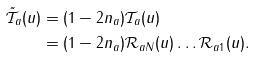Convert formula to latex. <formula><loc_0><loc_0><loc_500><loc_500>\mathcal { \tilde { T } } _ { a } ( u ) & = ( 1 - 2 n _ { a } ) \mathcal { T } _ { a } ( u ) \\ & = ( 1 - 2 n _ { a } ) \mathcal { R } _ { a N } ( u ) \dots \mathcal { R } _ { a 1 } ( u ) .</formula> 